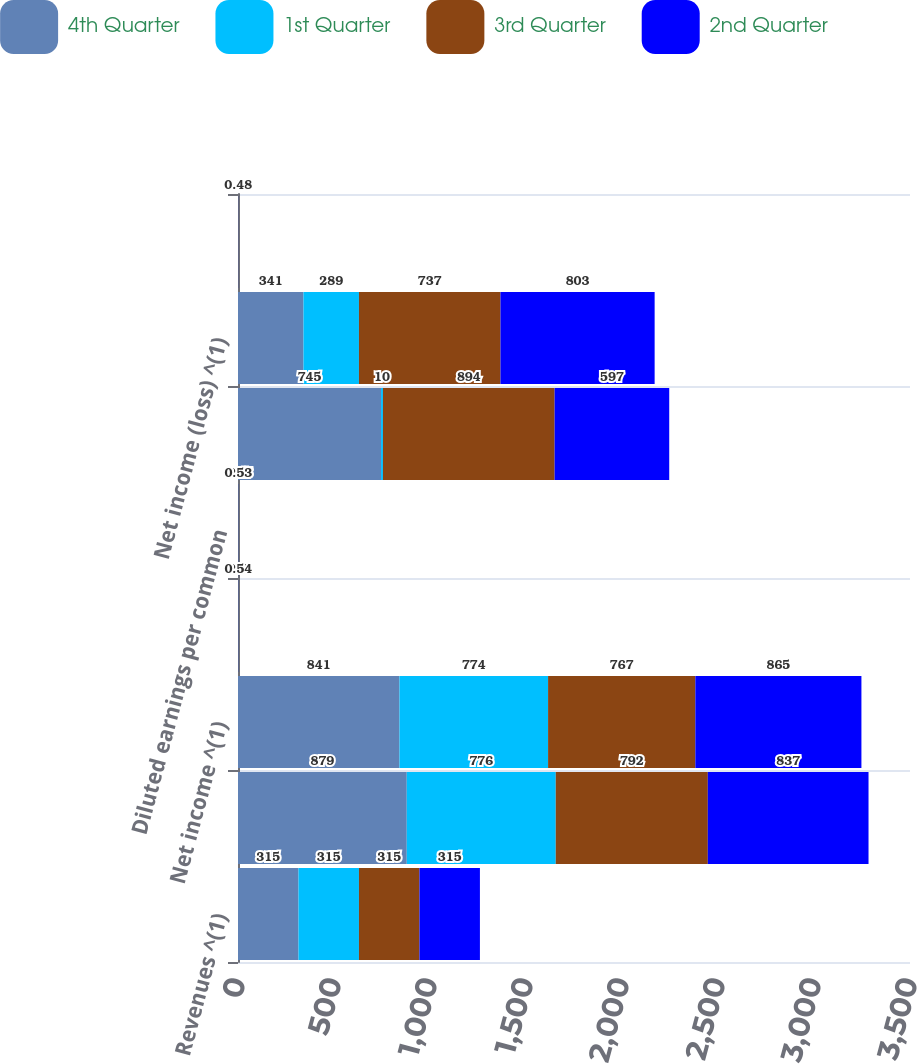Convert chart to OTSL. <chart><loc_0><loc_0><loc_500><loc_500><stacked_bar_chart><ecel><fcel>Revenues ^(1)<fcel>Operating income ^(1)<fcel>Net income ^(1)<fcel>Basic earnings per common<fcel>Diluted earnings per common<fcel>Operating income (loss) ^(1)<fcel>Net income (loss) ^(1)<fcel>Basic earnings (loss) per<nl><fcel>4th Quarter<fcel>315<fcel>879<fcel>841<fcel>0.5<fcel>0.5<fcel>745<fcel>341<fcel>0.21<nl><fcel>1st Quarter<fcel>315<fcel>776<fcel>774<fcel>0.47<fcel>0.46<fcel>10<fcel>289<fcel>0.18<nl><fcel>3rd Quarter<fcel>315<fcel>792<fcel>767<fcel>0.47<fcel>0.47<fcel>894<fcel>737<fcel>0.45<nl><fcel>2nd Quarter<fcel>315<fcel>837<fcel>865<fcel>0.54<fcel>0.53<fcel>597<fcel>803<fcel>0.48<nl></chart> 